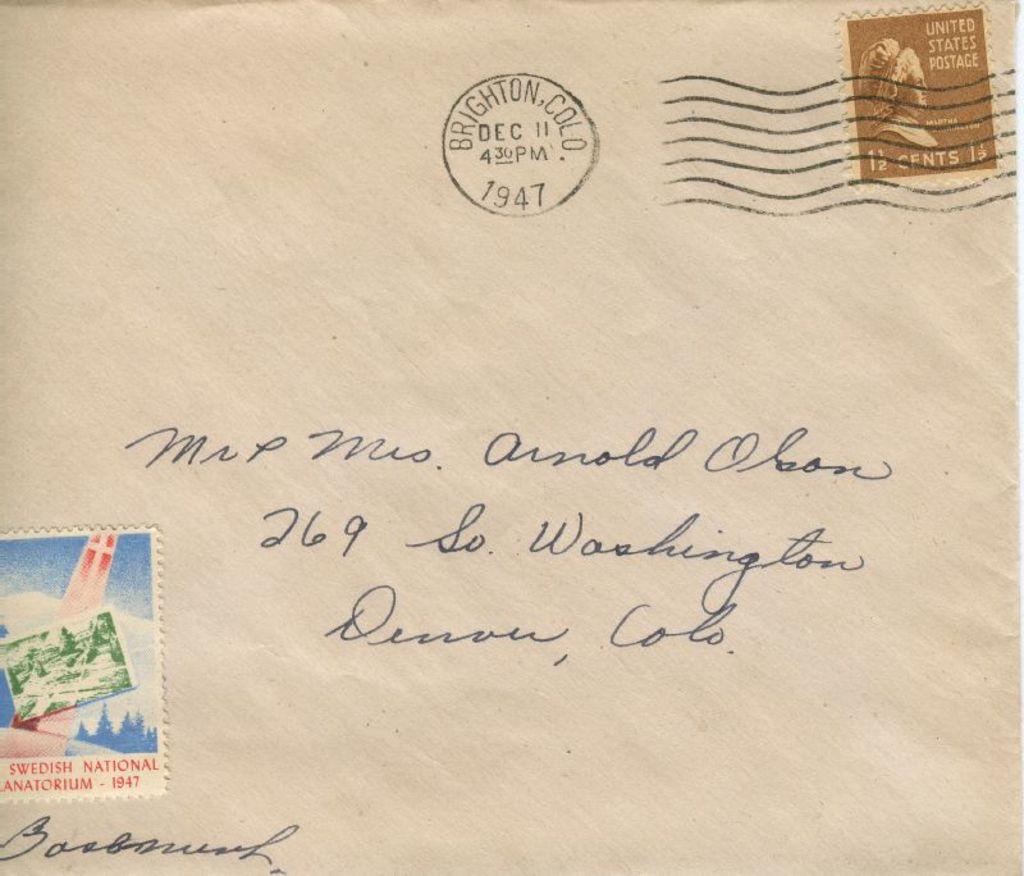What company postal stamp is on the top right?
Your answer should be compact. United states postage. What is the address line?
Your answer should be compact. 269 so. washington. 